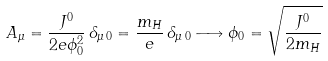<formula> <loc_0><loc_0><loc_500><loc_500>A _ { \mu } = \frac { J ^ { 0 } } { 2 e \phi _ { 0 } ^ { 2 } } \, \delta _ { \mu \, 0 } = \frac { m _ { H } } { e } \, \delta _ { \mu \, 0 } \longrightarrow \phi _ { 0 } = \sqrt { \frac { J ^ { 0 } } { 2 m _ { H } } }</formula> 